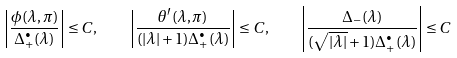Convert formula to latex. <formula><loc_0><loc_0><loc_500><loc_500>\left | \frac { \phi ( \lambda , \pi ) } { \Delta _ { + } ^ { \bullet } ( \lambda ) } \right | \leq C , \quad \left | \frac { \theta ^ { \prime } ( \lambda , \pi ) } { ( | \lambda | + 1 ) \Delta _ { + } ^ { \bullet } ( \lambda ) } \right | \leq C , \quad \left | \frac { \Delta _ { - } ( \lambda ) } { ( \sqrt { | { \lambda } | } + 1 ) \Delta _ { + } ^ { \bullet } ( \lambda ) } \right | \leq C</formula> 